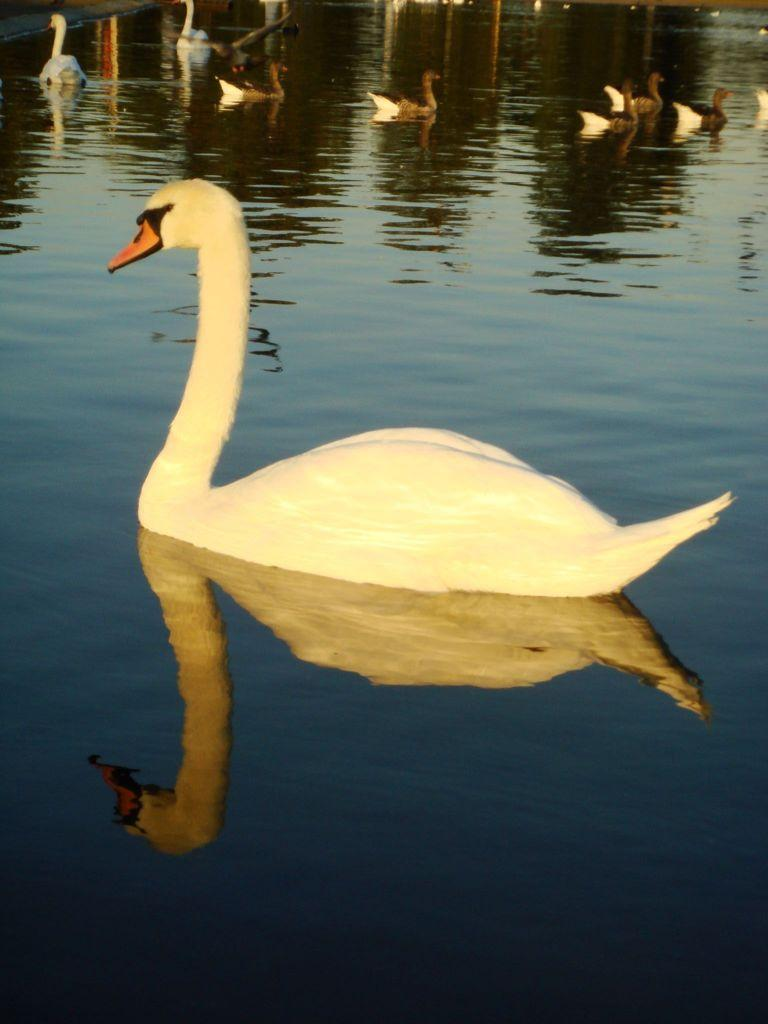What type of animals are in the image? There are swans in the image. Where are the swans located? The swans are present in water. What is the current debt situation of the swans in the image? There is no information about the swans' debt situation in the image, as swans do not have financial obligations. 